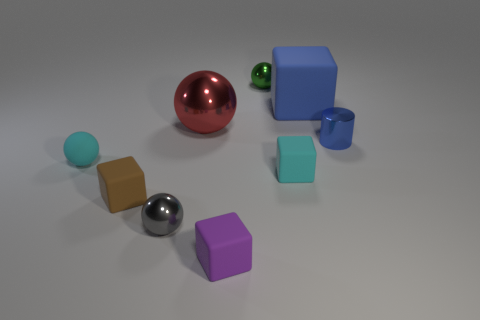Subtract all red metal spheres. How many spheres are left? 3 Add 1 large cyan matte cylinders. How many objects exist? 10 Subtract all cyan blocks. How many blocks are left? 3 Subtract 3 spheres. How many spheres are left? 1 Add 7 large blue blocks. How many large blue blocks are left? 8 Add 3 red things. How many red things exist? 4 Subtract 0 green cylinders. How many objects are left? 9 Subtract all cylinders. How many objects are left? 8 Subtract all purple blocks. Subtract all blue balls. How many blocks are left? 3 Subtract all green metallic spheres. Subtract all large shiny balls. How many objects are left? 7 